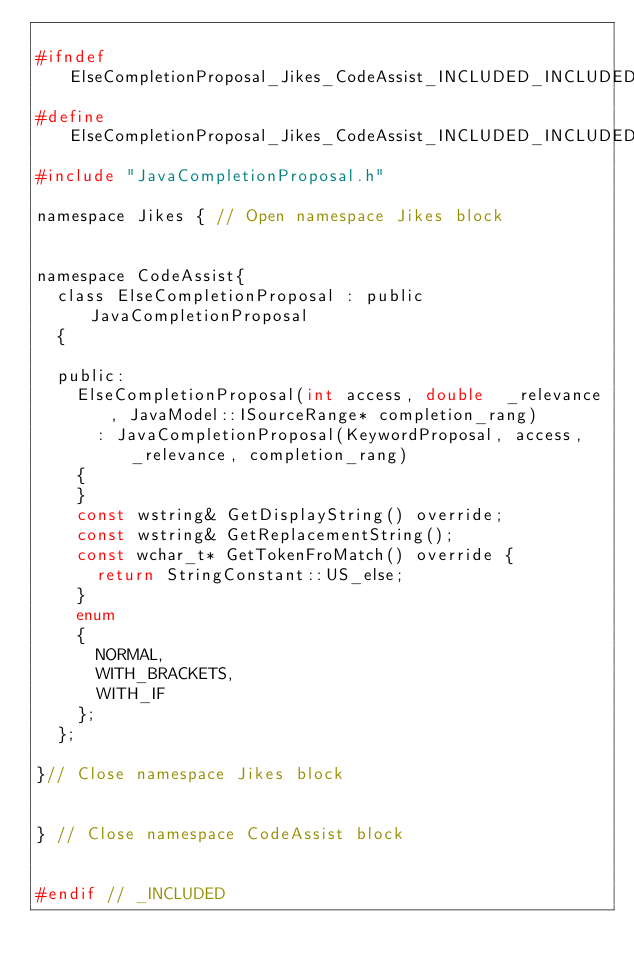Convert code to text. <code><loc_0><loc_0><loc_500><loc_500><_C_>
#ifndef ElseCompletionProposal_Jikes_CodeAssist_INCLUDED_INCLUDED
#define ElseCompletionProposal_Jikes_CodeAssist_INCLUDED_INCLUDED
#include "JavaCompletionProposal.h"

namespace Jikes { // Open namespace Jikes block


namespace CodeAssist{
	class ElseCompletionProposal : public JavaCompletionProposal
	{

	public:
		ElseCompletionProposal(int access, double  _relevance, JavaModel::ISourceRange* completion_rang)
			: JavaCompletionProposal(KeywordProposal, access, _relevance, completion_rang)
		{
		}
		const wstring& GetDisplayString() override;
		const wstring& GetReplacementString();
		const wchar_t* GetTokenFroMatch() override {
			return StringConstant::US_else;
		}
		enum
		{
			NORMAL,
			WITH_BRACKETS,
			WITH_IF
		};
	};

}// Close namespace Jikes block
	

} // Close namespace CodeAssist block


#endif // _INCLUDED

</code> 